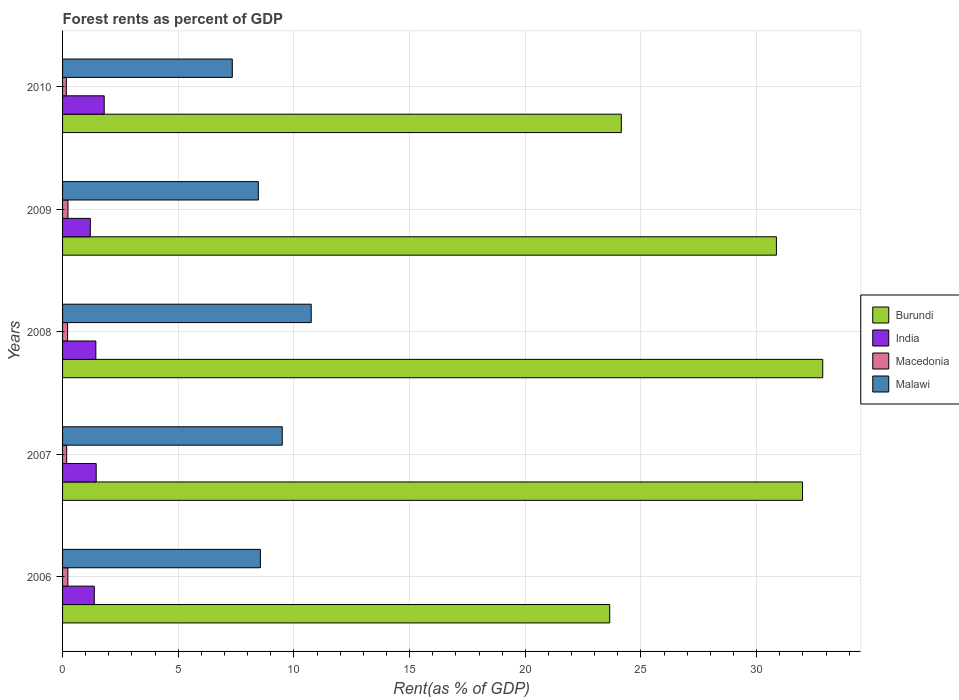How many different coloured bars are there?
Provide a succinct answer. 4. How many groups of bars are there?
Provide a succinct answer. 5. Are the number of bars per tick equal to the number of legend labels?
Provide a short and direct response. Yes. What is the label of the 5th group of bars from the top?
Your answer should be very brief. 2006. In how many cases, is the number of bars for a given year not equal to the number of legend labels?
Provide a succinct answer. 0. What is the forest rent in Malawi in 2009?
Ensure brevity in your answer.  8.46. Across all years, what is the maximum forest rent in Macedonia?
Ensure brevity in your answer.  0.23. Across all years, what is the minimum forest rent in Macedonia?
Your answer should be compact. 0.16. In which year was the forest rent in Burundi maximum?
Make the answer very short. 2008. In which year was the forest rent in India minimum?
Your answer should be compact. 2009. What is the total forest rent in Malawi in the graph?
Make the answer very short. 44.59. What is the difference between the forest rent in Macedonia in 2008 and that in 2010?
Offer a terse response. 0.05. What is the difference between the forest rent in India in 2006 and the forest rent in Burundi in 2009?
Your response must be concise. -29.48. What is the average forest rent in India per year?
Your response must be concise. 1.45. In the year 2008, what is the difference between the forest rent in Burundi and forest rent in India?
Give a very brief answer. 31.42. In how many years, is the forest rent in Burundi greater than 4 %?
Give a very brief answer. 5. What is the ratio of the forest rent in India in 2006 to that in 2009?
Ensure brevity in your answer.  1.14. Is the difference between the forest rent in Burundi in 2007 and 2010 greater than the difference between the forest rent in India in 2007 and 2010?
Offer a very short reply. Yes. What is the difference between the highest and the second highest forest rent in Macedonia?
Provide a succinct answer. 0. What is the difference between the highest and the lowest forest rent in Malawi?
Make the answer very short. 3.41. Is the sum of the forest rent in India in 2006 and 2007 greater than the maximum forest rent in Burundi across all years?
Offer a very short reply. No. Is it the case that in every year, the sum of the forest rent in India and forest rent in Malawi is greater than the sum of forest rent in Macedonia and forest rent in Burundi?
Make the answer very short. Yes. What does the 3rd bar from the top in 2007 represents?
Offer a terse response. India. What does the 4th bar from the bottom in 2009 represents?
Keep it short and to the point. Malawi. Is it the case that in every year, the sum of the forest rent in Burundi and forest rent in Macedonia is greater than the forest rent in India?
Your answer should be compact. Yes. Are all the bars in the graph horizontal?
Keep it short and to the point. Yes. How many years are there in the graph?
Make the answer very short. 5. What is the difference between two consecutive major ticks on the X-axis?
Offer a very short reply. 5. Are the values on the major ticks of X-axis written in scientific E-notation?
Offer a terse response. No. Does the graph contain any zero values?
Keep it short and to the point. No. Does the graph contain grids?
Make the answer very short. Yes. What is the title of the graph?
Provide a short and direct response. Forest rents as percent of GDP. What is the label or title of the X-axis?
Provide a succinct answer. Rent(as % of GDP). What is the Rent(as % of GDP) in Burundi in 2006?
Offer a very short reply. 23.65. What is the Rent(as % of GDP) of India in 2006?
Offer a terse response. 1.37. What is the Rent(as % of GDP) in Macedonia in 2006?
Offer a terse response. 0.23. What is the Rent(as % of GDP) in Malawi in 2006?
Your answer should be compact. 8.55. What is the Rent(as % of GDP) of Burundi in 2007?
Your answer should be compact. 31.98. What is the Rent(as % of GDP) of India in 2007?
Offer a terse response. 1.45. What is the Rent(as % of GDP) of Macedonia in 2007?
Provide a short and direct response. 0.18. What is the Rent(as % of GDP) of Malawi in 2007?
Make the answer very short. 9.49. What is the Rent(as % of GDP) of Burundi in 2008?
Give a very brief answer. 32.86. What is the Rent(as % of GDP) in India in 2008?
Your answer should be very brief. 1.44. What is the Rent(as % of GDP) in Macedonia in 2008?
Your response must be concise. 0.22. What is the Rent(as % of GDP) of Malawi in 2008?
Provide a short and direct response. 10.75. What is the Rent(as % of GDP) in Burundi in 2009?
Keep it short and to the point. 30.85. What is the Rent(as % of GDP) in India in 2009?
Ensure brevity in your answer.  1.2. What is the Rent(as % of GDP) of Macedonia in 2009?
Your response must be concise. 0.23. What is the Rent(as % of GDP) in Malawi in 2009?
Provide a succinct answer. 8.46. What is the Rent(as % of GDP) of Burundi in 2010?
Provide a succinct answer. 24.15. What is the Rent(as % of GDP) of India in 2010?
Your answer should be compact. 1.8. What is the Rent(as % of GDP) in Macedonia in 2010?
Keep it short and to the point. 0.16. What is the Rent(as % of GDP) in Malawi in 2010?
Offer a terse response. 7.34. Across all years, what is the maximum Rent(as % of GDP) in Burundi?
Offer a terse response. 32.86. Across all years, what is the maximum Rent(as % of GDP) in India?
Give a very brief answer. 1.8. Across all years, what is the maximum Rent(as % of GDP) in Macedonia?
Make the answer very short. 0.23. Across all years, what is the maximum Rent(as % of GDP) in Malawi?
Keep it short and to the point. 10.75. Across all years, what is the minimum Rent(as % of GDP) in Burundi?
Your response must be concise. 23.65. Across all years, what is the minimum Rent(as % of GDP) in India?
Ensure brevity in your answer.  1.2. Across all years, what is the minimum Rent(as % of GDP) in Macedonia?
Offer a terse response. 0.16. Across all years, what is the minimum Rent(as % of GDP) of Malawi?
Keep it short and to the point. 7.34. What is the total Rent(as % of GDP) of Burundi in the graph?
Make the answer very short. 143.49. What is the total Rent(as % of GDP) in India in the graph?
Provide a short and direct response. 7.26. What is the total Rent(as % of GDP) of Macedonia in the graph?
Offer a terse response. 1.02. What is the total Rent(as % of GDP) of Malawi in the graph?
Your answer should be compact. 44.59. What is the difference between the Rent(as % of GDP) of Burundi in 2006 and that in 2007?
Give a very brief answer. -8.33. What is the difference between the Rent(as % of GDP) of India in 2006 and that in 2007?
Your answer should be very brief. -0.08. What is the difference between the Rent(as % of GDP) in Macedonia in 2006 and that in 2007?
Give a very brief answer. 0.05. What is the difference between the Rent(as % of GDP) of Malawi in 2006 and that in 2007?
Offer a terse response. -0.94. What is the difference between the Rent(as % of GDP) of Burundi in 2006 and that in 2008?
Provide a succinct answer. -9.21. What is the difference between the Rent(as % of GDP) of India in 2006 and that in 2008?
Make the answer very short. -0.07. What is the difference between the Rent(as % of GDP) of Macedonia in 2006 and that in 2008?
Your answer should be very brief. 0.01. What is the difference between the Rent(as % of GDP) of Malawi in 2006 and that in 2008?
Make the answer very short. -2.2. What is the difference between the Rent(as % of GDP) in Burundi in 2006 and that in 2009?
Offer a very short reply. -7.2. What is the difference between the Rent(as % of GDP) of India in 2006 and that in 2009?
Keep it short and to the point. 0.17. What is the difference between the Rent(as % of GDP) of Macedonia in 2006 and that in 2009?
Make the answer very short. -0. What is the difference between the Rent(as % of GDP) in Malawi in 2006 and that in 2009?
Your answer should be very brief. 0.09. What is the difference between the Rent(as % of GDP) of Burundi in 2006 and that in 2010?
Your answer should be very brief. -0.5. What is the difference between the Rent(as % of GDP) of India in 2006 and that in 2010?
Offer a terse response. -0.43. What is the difference between the Rent(as % of GDP) of Macedonia in 2006 and that in 2010?
Offer a very short reply. 0.07. What is the difference between the Rent(as % of GDP) in Malawi in 2006 and that in 2010?
Provide a succinct answer. 1.21. What is the difference between the Rent(as % of GDP) in Burundi in 2007 and that in 2008?
Your answer should be compact. -0.87. What is the difference between the Rent(as % of GDP) in India in 2007 and that in 2008?
Offer a very short reply. 0.02. What is the difference between the Rent(as % of GDP) of Macedonia in 2007 and that in 2008?
Ensure brevity in your answer.  -0.04. What is the difference between the Rent(as % of GDP) of Malawi in 2007 and that in 2008?
Your answer should be very brief. -1.25. What is the difference between the Rent(as % of GDP) in Burundi in 2007 and that in 2009?
Your answer should be compact. 1.13. What is the difference between the Rent(as % of GDP) in India in 2007 and that in 2009?
Give a very brief answer. 0.25. What is the difference between the Rent(as % of GDP) in Macedonia in 2007 and that in 2009?
Make the answer very short. -0.06. What is the difference between the Rent(as % of GDP) of Malawi in 2007 and that in 2009?
Provide a short and direct response. 1.03. What is the difference between the Rent(as % of GDP) in Burundi in 2007 and that in 2010?
Ensure brevity in your answer.  7.83. What is the difference between the Rent(as % of GDP) of India in 2007 and that in 2010?
Your answer should be very brief. -0.35. What is the difference between the Rent(as % of GDP) of Macedonia in 2007 and that in 2010?
Your answer should be very brief. 0.01. What is the difference between the Rent(as % of GDP) in Malawi in 2007 and that in 2010?
Offer a very short reply. 2.16. What is the difference between the Rent(as % of GDP) of Burundi in 2008 and that in 2009?
Keep it short and to the point. 2. What is the difference between the Rent(as % of GDP) of India in 2008 and that in 2009?
Offer a terse response. 0.24. What is the difference between the Rent(as % of GDP) of Macedonia in 2008 and that in 2009?
Ensure brevity in your answer.  -0.01. What is the difference between the Rent(as % of GDP) of Malawi in 2008 and that in 2009?
Make the answer very short. 2.29. What is the difference between the Rent(as % of GDP) of Burundi in 2008 and that in 2010?
Your response must be concise. 8.71. What is the difference between the Rent(as % of GDP) in India in 2008 and that in 2010?
Ensure brevity in your answer.  -0.36. What is the difference between the Rent(as % of GDP) in Macedonia in 2008 and that in 2010?
Provide a short and direct response. 0.05. What is the difference between the Rent(as % of GDP) in Malawi in 2008 and that in 2010?
Give a very brief answer. 3.41. What is the difference between the Rent(as % of GDP) of Burundi in 2009 and that in 2010?
Keep it short and to the point. 6.7. What is the difference between the Rent(as % of GDP) of India in 2009 and that in 2010?
Make the answer very short. -0.6. What is the difference between the Rent(as % of GDP) in Macedonia in 2009 and that in 2010?
Give a very brief answer. 0.07. What is the difference between the Rent(as % of GDP) of Malawi in 2009 and that in 2010?
Give a very brief answer. 1.12. What is the difference between the Rent(as % of GDP) in Burundi in 2006 and the Rent(as % of GDP) in India in 2007?
Your answer should be very brief. 22.2. What is the difference between the Rent(as % of GDP) in Burundi in 2006 and the Rent(as % of GDP) in Macedonia in 2007?
Provide a short and direct response. 23.47. What is the difference between the Rent(as % of GDP) of Burundi in 2006 and the Rent(as % of GDP) of Malawi in 2007?
Make the answer very short. 14.15. What is the difference between the Rent(as % of GDP) of India in 2006 and the Rent(as % of GDP) of Macedonia in 2007?
Make the answer very short. 1.19. What is the difference between the Rent(as % of GDP) of India in 2006 and the Rent(as % of GDP) of Malawi in 2007?
Offer a terse response. -8.12. What is the difference between the Rent(as % of GDP) in Macedonia in 2006 and the Rent(as % of GDP) in Malawi in 2007?
Provide a succinct answer. -9.27. What is the difference between the Rent(as % of GDP) of Burundi in 2006 and the Rent(as % of GDP) of India in 2008?
Give a very brief answer. 22.21. What is the difference between the Rent(as % of GDP) of Burundi in 2006 and the Rent(as % of GDP) of Macedonia in 2008?
Give a very brief answer. 23.43. What is the difference between the Rent(as % of GDP) of Burundi in 2006 and the Rent(as % of GDP) of Malawi in 2008?
Your answer should be compact. 12.9. What is the difference between the Rent(as % of GDP) in India in 2006 and the Rent(as % of GDP) in Macedonia in 2008?
Your answer should be very brief. 1.15. What is the difference between the Rent(as % of GDP) of India in 2006 and the Rent(as % of GDP) of Malawi in 2008?
Your response must be concise. -9.38. What is the difference between the Rent(as % of GDP) in Macedonia in 2006 and the Rent(as % of GDP) in Malawi in 2008?
Provide a short and direct response. -10.52. What is the difference between the Rent(as % of GDP) in Burundi in 2006 and the Rent(as % of GDP) in India in 2009?
Offer a very short reply. 22.45. What is the difference between the Rent(as % of GDP) of Burundi in 2006 and the Rent(as % of GDP) of Macedonia in 2009?
Offer a very short reply. 23.42. What is the difference between the Rent(as % of GDP) of Burundi in 2006 and the Rent(as % of GDP) of Malawi in 2009?
Make the answer very short. 15.19. What is the difference between the Rent(as % of GDP) of India in 2006 and the Rent(as % of GDP) of Macedonia in 2009?
Give a very brief answer. 1.14. What is the difference between the Rent(as % of GDP) of India in 2006 and the Rent(as % of GDP) of Malawi in 2009?
Offer a very short reply. -7.09. What is the difference between the Rent(as % of GDP) of Macedonia in 2006 and the Rent(as % of GDP) of Malawi in 2009?
Your answer should be compact. -8.23. What is the difference between the Rent(as % of GDP) of Burundi in 2006 and the Rent(as % of GDP) of India in 2010?
Provide a short and direct response. 21.85. What is the difference between the Rent(as % of GDP) of Burundi in 2006 and the Rent(as % of GDP) of Macedonia in 2010?
Offer a very short reply. 23.49. What is the difference between the Rent(as % of GDP) of Burundi in 2006 and the Rent(as % of GDP) of Malawi in 2010?
Give a very brief answer. 16.31. What is the difference between the Rent(as % of GDP) in India in 2006 and the Rent(as % of GDP) in Macedonia in 2010?
Make the answer very short. 1.21. What is the difference between the Rent(as % of GDP) of India in 2006 and the Rent(as % of GDP) of Malawi in 2010?
Ensure brevity in your answer.  -5.96. What is the difference between the Rent(as % of GDP) of Macedonia in 2006 and the Rent(as % of GDP) of Malawi in 2010?
Your answer should be compact. -7.11. What is the difference between the Rent(as % of GDP) of Burundi in 2007 and the Rent(as % of GDP) of India in 2008?
Provide a short and direct response. 30.54. What is the difference between the Rent(as % of GDP) in Burundi in 2007 and the Rent(as % of GDP) in Macedonia in 2008?
Provide a succinct answer. 31.76. What is the difference between the Rent(as % of GDP) in Burundi in 2007 and the Rent(as % of GDP) in Malawi in 2008?
Ensure brevity in your answer.  21.24. What is the difference between the Rent(as % of GDP) of India in 2007 and the Rent(as % of GDP) of Macedonia in 2008?
Ensure brevity in your answer.  1.24. What is the difference between the Rent(as % of GDP) in India in 2007 and the Rent(as % of GDP) in Malawi in 2008?
Your answer should be compact. -9.29. What is the difference between the Rent(as % of GDP) of Macedonia in 2007 and the Rent(as % of GDP) of Malawi in 2008?
Make the answer very short. -10.57. What is the difference between the Rent(as % of GDP) of Burundi in 2007 and the Rent(as % of GDP) of India in 2009?
Your answer should be very brief. 30.78. What is the difference between the Rent(as % of GDP) of Burundi in 2007 and the Rent(as % of GDP) of Macedonia in 2009?
Your answer should be very brief. 31.75. What is the difference between the Rent(as % of GDP) of Burundi in 2007 and the Rent(as % of GDP) of Malawi in 2009?
Your response must be concise. 23.52. What is the difference between the Rent(as % of GDP) of India in 2007 and the Rent(as % of GDP) of Macedonia in 2009?
Keep it short and to the point. 1.22. What is the difference between the Rent(as % of GDP) of India in 2007 and the Rent(as % of GDP) of Malawi in 2009?
Offer a terse response. -7.01. What is the difference between the Rent(as % of GDP) of Macedonia in 2007 and the Rent(as % of GDP) of Malawi in 2009?
Your answer should be very brief. -8.28. What is the difference between the Rent(as % of GDP) in Burundi in 2007 and the Rent(as % of GDP) in India in 2010?
Offer a terse response. 30.18. What is the difference between the Rent(as % of GDP) in Burundi in 2007 and the Rent(as % of GDP) in Macedonia in 2010?
Keep it short and to the point. 31.82. What is the difference between the Rent(as % of GDP) of Burundi in 2007 and the Rent(as % of GDP) of Malawi in 2010?
Ensure brevity in your answer.  24.65. What is the difference between the Rent(as % of GDP) in India in 2007 and the Rent(as % of GDP) in Macedonia in 2010?
Ensure brevity in your answer.  1.29. What is the difference between the Rent(as % of GDP) of India in 2007 and the Rent(as % of GDP) of Malawi in 2010?
Ensure brevity in your answer.  -5.88. What is the difference between the Rent(as % of GDP) of Macedonia in 2007 and the Rent(as % of GDP) of Malawi in 2010?
Keep it short and to the point. -7.16. What is the difference between the Rent(as % of GDP) of Burundi in 2008 and the Rent(as % of GDP) of India in 2009?
Offer a very short reply. 31.66. What is the difference between the Rent(as % of GDP) in Burundi in 2008 and the Rent(as % of GDP) in Macedonia in 2009?
Keep it short and to the point. 32.62. What is the difference between the Rent(as % of GDP) of Burundi in 2008 and the Rent(as % of GDP) of Malawi in 2009?
Your response must be concise. 24.39. What is the difference between the Rent(as % of GDP) of India in 2008 and the Rent(as % of GDP) of Macedonia in 2009?
Your answer should be compact. 1.21. What is the difference between the Rent(as % of GDP) in India in 2008 and the Rent(as % of GDP) in Malawi in 2009?
Provide a succinct answer. -7.02. What is the difference between the Rent(as % of GDP) in Macedonia in 2008 and the Rent(as % of GDP) in Malawi in 2009?
Your response must be concise. -8.24. What is the difference between the Rent(as % of GDP) of Burundi in 2008 and the Rent(as % of GDP) of India in 2010?
Keep it short and to the point. 31.06. What is the difference between the Rent(as % of GDP) of Burundi in 2008 and the Rent(as % of GDP) of Macedonia in 2010?
Make the answer very short. 32.69. What is the difference between the Rent(as % of GDP) of Burundi in 2008 and the Rent(as % of GDP) of Malawi in 2010?
Keep it short and to the point. 25.52. What is the difference between the Rent(as % of GDP) of India in 2008 and the Rent(as % of GDP) of Macedonia in 2010?
Give a very brief answer. 1.28. What is the difference between the Rent(as % of GDP) in India in 2008 and the Rent(as % of GDP) in Malawi in 2010?
Your response must be concise. -5.9. What is the difference between the Rent(as % of GDP) of Macedonia in 2008 and the Rent(as % of GDP) of Malawi in 2010?
Your response must be concise. -7.12. What is the difference between the Rent(as % of GDP) in Burundi in 2009 and the Rent(as % of GDP) in India in 2010?
Keep it short and to the point. 29.05. What is the difference between the Rent(as % of GDP) in Burundi in 2009 and the Rent(as % of GDP) in Macedonia in 2010?
Give a very brief answer. 30.69. What is the difference between the Rent(as % of GDP) in Burundi in 2009 and the Rent(as % of GDP) in Malawi in 2010?
Make the answer very short. 23.52. What is the difference between the Rent(as % of GDP) in India in 2009 and the Rent(as % of GDP) in Macedonia in 2010?
Your answer should be very brief. 1.04. What is the difference between the Rent(as % of GDP) in India in 2009 and the Rent(as % of GDP) in Malawi in 2010?
Offer a terse response. -6.14. What is the difference between the Rent(as % of GDP) of Macedonia in 2009 and the Rent(as % of GDP) of Malawi in 2010?
Offer a terse response. -7.1. What is the average Rent(as % of GDP) in Burundi per year?
Ensure brevity in your answer.  28.7. What is the average Rent(as % of GDP) in India per year?
Your response must be concise. 1.45. What is the average Rent(as % of GDP) of Macedonia per year?
Your answer should be very brief. 0.2. What is the average Rent(as % of GDP) in Malawi per year?
Offer a very short reply. 8.92. In the year 2006, what is the difference between the Rent(as % of GDP) of Burundi and Rent(as % of GDP) of India?
Offer a terse response. 22.28. In the year 2006, what is the difference between the Rent(as % of GDP) of Burundi and Rent(as % of GDP) of Macedonia?
Your response must be concise. 23.42. In the year 2006, what is the difference between the Rent(as % of GDP) of Burundi and Rent(as % of GDP) of Malawi?
Keep it short and to the point. 15.1. In the year 2006, what is the difference between the Rent(as % of GDP) of India and Rent(as % of GDP) of Macedonia?
Ensure brevity in your answer.  1.14. In the year 2006, what is the difference between the Rent(as % of GDP) in India and Rent(as % of GDP) in Malawi?
Your answer should be very brief. -7.18. In the year 2006, what is the difference between the Rent(as % of GDP) of Macedonia and Rent(as % of GDP) of Malawi?
Your answer should be compact. -8.32. In the year 2007, what is the difference between the Rent(as % of GDP) of Burundi and Rent(as % of GDP) of India?
Provide a succinct answer. 30.53. In the year 2007, what is the difference between the Rent(as % of GDP) of Burundi and Rent(as % of GDP) of Macedonia?
Give a very brief answer. 31.81. In the year 2007, what is the difference between the Rent(as % of GDP) of Burundi and Rent(as % of GDP) of Malawi?
Provide a succinct answer. 22.49. In the year 2007, what is the difference between the Rent(as % of GDP) in India and Rent(as % of GDP) in Macedonia?
Offer a very short reply. 1.28. In the year 2007, what is the difference between the Rent(as % of GDP) in India and Rent(as % of GDP) in Malawi?
Provide a short and direct response. -8.04. In the year 2007, what is the difference between the Rent(as % of GDP) of Macedonia and Rent(as % of GDP) of Malawi?
Your response must be concise. -9.32. In the year 2008, what is the difference between the Rent(as % of GDP) in Burundi and Rent(as % of GDP) in India?
Ensure brevity in your answer.  31.42. In the year 2008, what is the difference between the Rent(as % of GDP) of Burundi and Rent(as % of GDP) of Macedonia?
Provide a short and direct response. 32.64. In the year 2008, what is the difference between the Rent(as % of GDP) in Burundi and Rent(as % of GDP) in Malawi?
Provide a succinct answer. 22.11. In the year 2008, what is the difference between the Rent(as % of GDP) of India and Rent(as % of GDP) of Macedonia?
Provide a short and direct response. 1.22. In the year 2008, what is the difference between the Rent(as % of GDP) of India and Rent(as % of GDP) of Malawi?
Your response must be concise. -9.31. In the year 2008, what is the difference between the Rent(as % of GDP) in Macedonia and Rent(as % of GDP) in Malawi?
Provide a short and direct response. -10.53. In the year 2009, what is the difference between the Rent(as % of GDP) of Burundi and Rent(as % of GDP) of India?
Ensure brevity in your answer.  29.65. In the year 2009, what is the difference between the Rent(as % of GDP) in Burundi and Rent(as % of GDP) in Macedonia?
Ensure brevity in your answer.  30.62. In the year 2009, what is the difference between the Rent(as % of GDP) of Burundi and Rent(as % of GDP) of Malawi?
Your response must be concise. 22.39. In the year 2009, what is the difference between the Rent(as % of GDP) in India and Rent(as % of GDP) in Macedonia?
Your answer should be very brief. 0.97. In the year 2009, what is the difference between the Rent(as % of GDP) of India and Rent(as % of GDP) of Malawi?
Offer a very short reply. -7.26. In the year 2009, what is the difference between the Rent(as % of GDP) in Macedonia and Rent(as % of GDP) in Malawi?
Ensure brevity in your answer.  -8.23. In the year 2010, what is the difference between the Rent(as % of GDP) of Burundi and Rent(as % of GDP) of India?
Offer a terse response. 22.35. In the year 2010, what is the difference between the Rent(as % of GDP) of Burundi and Rent(as % of GDP) of Macedonia?
Give a very brief answer. 23.99. In the year 2010, what is the difference between the Rent(as % of GDP) in Burundi and Rent(as % of GDP) in Malawi?
Your answer should be very brief. 16.81. In the year 2010, what is the difference between the Rent(as % of GDP) in India and Rent(as % of GDP) in Macedonia?
Your answer should be compact. 1.64. In the year 2010, what is the difference between the Rent(as % of GDP) of India and Rent(as % of GDP) of Malawi?
Your answer should be compact. -5.54. In the year 2010, what is the difference between the Rent(as % of GDP) of Macedonia and Rent(as % of GDP) of Malawi?
Provide a succinct answer. -7.17. What is the ratio of the Rent(as % of GDP) of Burundi in 2006 to that in 2007?
Your response must be concise. 0.74. What is the ratio of the Rent(as % of GDP) in India in 2006 to that in 2007?
Your answer should be very brief. 0.94. What is the ratio of the Rent(as % of GDP) of Macedonia in 2006 to that in 2007?
Offer a very short reply. 1.3. What is the ratio of the Rent(as % of GDP) in Malawi in 2006 to that in 2007?
Provide a short and direct response. 0.9. What is the ratio of the Rent(as % of GDP) of Burundi in 2006 to that in 2008?
Your answer should be very brief. 0.72. What is the ratio of the Rent(as % of GDP) in India in 2006 to that in 2008?
Ensure brevity in your answer.  0.95. What is the ratio of the Rent(as % of GDP) of Macedonia in 2006 to that in 2008?
Keep it short and to the point. 1.05. What is the ratio of the Rent(as % of GDP) in Malawi in 2006 to that in 2008?
Your answer should be very brief. 0.8. What is the ratio of the Rent(as % of GDP) of Burundi in 2006 to that in 2009?
Your answer should be compact. 0.77. What is the ratio of the Rent(as % of GDP) in India in 2006 to that in 2009?
Keep it short and to the point. 1.14. What is the ratio of the Rent(as % of GDP) of Macedonia in 2006 to that in 2009?
Offer a terse response. 0.99. What is the ratio of the Rent(as % of GDP) of Malawi in 2006 to that in 2009?
Offer a very short reply. 1.01. What is the ratio of the Rent(as % of GDP) in Burundi in 2006 to that in 2010?
Give a very brief answer. 0.98. What is the ratio of the Rent(as % of GDP) in India in 2006 to that in 2010?
Offer a terse response. 0.76. What is the ratio of the Rent(as % of GDP) in Macedonia in 2006 to that in 2010?
Give a very brief answer. 1.41. What is the ratio of the Rent(as % of GDP) of Malawi in 2006 to that in 2010?
Your answer should be compact. 1.17. What is the ratio of the Rent(as % of GDP) in Burundi in 2007 to that in 2008?
Provide a short and direct response. 0.97. What is the ratio of the Rent(as % of GDP) in India in 2007 to that in 2008?
Provide a short and direct response. 1.01. What is the ratio of the Rent(as % of GDP) in Macedonia in 2007 to that in 2008?
Make the answer very short. 0.81. What is the ratio of the Rent(as % of GDP) in Malawi in 2007 to that in 2008?
Your answer should be very brief. 0.88. What is the ratio of the Rent(as % of GDP) of Burundi in 2007 to that in 2009?
Provide a short and direct response. 1.04. What is the ratio of the Rent(as % of GDP) of India in 2007 to that in 2009?
Give a very brief answer. 1.21. What is the ratio of the Rent(as % of GDP) of Macedonia in 2007 to that in 2009?
Your answer should be compact. 0.76. What is the ratio of the Rent(as % of GDP) in Malawi in 2007 to that in 2009?
Offer a terse response. 1.12. What is the ratio of the Rent(as % of GDP) in Burundi in 2007 to that in 2010?
Offer a terse response. 1.32. What is the ratio of the Rent(as % of GDP) in India in 2007 to that in 2010?
Your response must be concise. 0.81. What is the ratio of the Rent(as % of GDP) in Macedonia in 2007 to that in 2010?
Make the answer very short. 1.08. What is the ratio of the Rent(as % of GDP) of Malawi in 2007 to that in 2010?
Your answer should be very brief. 1.29. What is the ratio of the Rent(as % of GDP) of Burundi in 2008 to that in 2009?
Provide a succinct answer. 1.06. What is the ratio of the Rent(as % of GDP) in India in 2008 to that in 2009?
Provide a succinct answer. 1.2. What is the ratio of the Rent(as % of GDP) of Macedonia in 2008 to that in 2009?
Provide a succinct answer. 0.94. What is the ratio of the Rent(as % of GDP) in Malawi in 2008 to that in 2009?
Your answer should be compact. 1.27. What is the ratio of the Rent(as % of GDP) of Burundi in 2008 to that in 2010?
Your answer should be compact. 1.36. What is the ratio of the Rent(as % of GDP) of India in 2008 to that in 2010?
Give a very brief answer. 0.8. What is the ratio of the Rent(as % of GDP) in Macedonia in 2008 to that in 2010?
Offer a terse response. 1.33. What is the ratio of the Rent(as % of GDP) in Malawi in 2008 to that in 2010?
Your response must be concise. 1.46. What is the ratio of the Rent(as % of GDP) of Burundi in 2009 to that in 2010?
Offer a terse response. 1.28. What is the ratio of the Rent(as % of GDP) of India in 2009 to that in 2010?
Ensure brevity in your answer.  0.67. What is the ratio of the Rent(as % of GDP) of Macedonia in 2009 to that in 2010?
Keep it short and to the point. 1.43. What is the ratio of the Rent(as % of GDP) of Malawi in 2009 to that in 2010?
Offer a terse response. 1.15. What is the difference between the highest and the second highest Rent(as % of GDP) in Burundi?
Ensure brevity in your answer.  0.87. What is the difference between the highest and the second highest Rent(as % of GDP) of India?
Your answer should be very brief. 0.35. What is the difference between the highest and the second highest Rent(as % of GDP) in Macedonia?
Provide a short and direct response. 0. What is the difference between the highest and the second highest Rent(as % of GDP) of Malawi?
Make the answer very short. 1.25. What is the difference between the highest and the lowest Rent(as % of GDP) in Burundi?
Offer a very short reply. 9.21. What is the difference between the highest and the lowest Rent(as % of GDP) in India?
Offer a terse response. 0.6. What is the difference between the highest and the lowest Rent(as % of GDP) in Macedonia?
Ensure brevity in your answer.  0.07. What is the difference between the highest and the lowest Rent(as % of GDP) in Malawi?
Offer a very short reply. 3.41. 